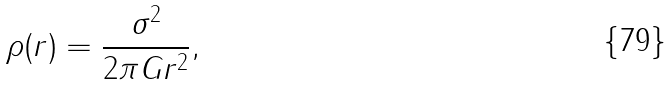Convert formula to latex. <formula><loc_0><loc_0><loc_500><loc_500>\rho ( r ) = \frac { \sigma ^ { 2 } } { 2 \pi G r ^ { 2 } } ,</formula> 